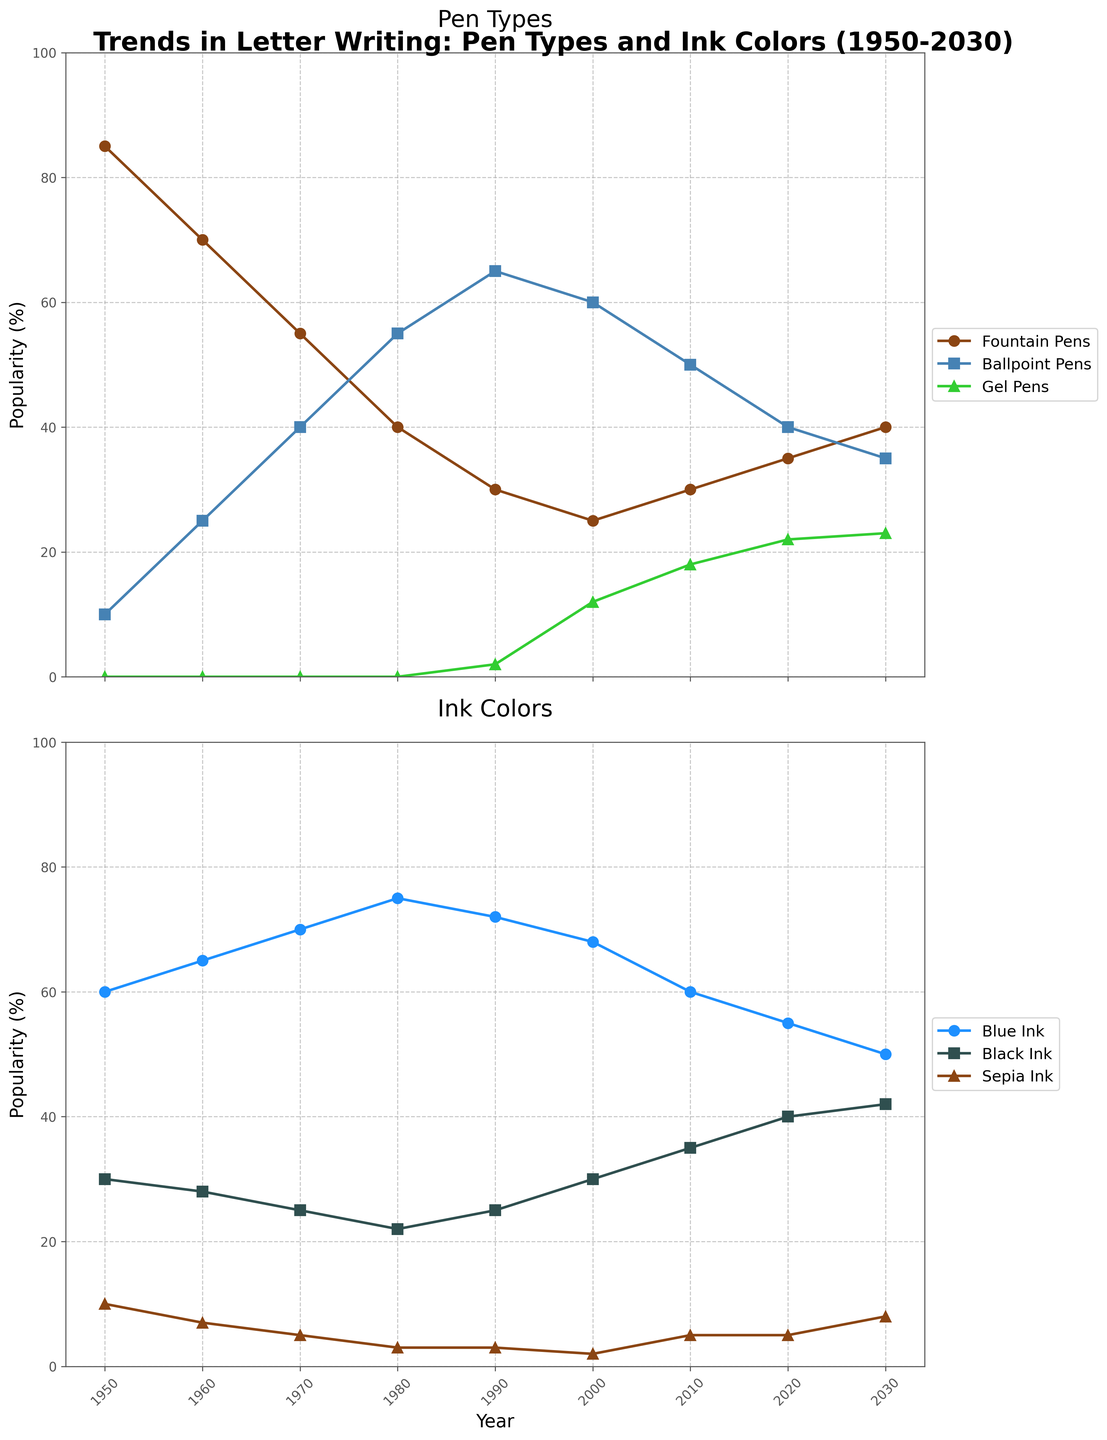what is the trend of fountain pens' popularity from 1950 to 2030? From the figure, the popularity of fountain pens declines from 85% in 1950 to a low of 25% in 2000 after which it starts to gradually increase, reaching up to 40% by 2030.
Answer: An initial decline, followed by a gradual increase Are gel pens more popular than ballpoint pens in 2030? In the figure, gel pens are at 23% while ballpoint pens are at 35% in 2030. Since 23% is less than 35%, gel pens are less popular than ballpoint pens in 2030.
Answer: No In which year did ballpoint pens surpass fountain pens in popularity? According to the figure, ballpoint pens’ popularity exceeds that of fountain pens between 1970 and 1980. In 1970, ballpoint pens are at 40% compared to fountain pens at 55%. By 1980, ballpoint pens reach 55%, and fountain pens fall to 40%. Thus, ballpoint pens surpass fountain pens around 1975.
Answer: Around 1975 What is the total combined popularity of blue ink, black ink, and sepia ink in 2020? From the figure, blue ink is at 55%, black ink at 40%, and sepia ink at 5% in 2020. Adding these percentages gives 55% + 40% + 5% = 100%.
Answer: 100% How does the popularity of sepia ink change from 1950 to 2030? According to the figure, sepia ink starts at 10% in 1950, gradually declines to 2% in 2000, then slightly increases to 8% by 2030.
Answer: Gradual decline followed by a slight increase Which ink color surpasses the other in popularity around 2000, blue ink or black ink? In the year 2000, the popularity of blue ink is 68% while black ink is 30%. Comparing these percentages, blue ink is more popular than black ink.
Answer: Blue ink What is the average popularity of ballpoint pens from 1950 to 2030? To find the average, add the popularity of ballpoint pens for all years given and divide by the number of years: (10 + 25 + 40 + 55 + 65 + 60 + 50 + 40 + 35) / 9. Summing these up gives 380. Dividing by 9, the average is 42.22.
Answer: 42.22% In which year is the popularity of fountain pens and gel pens equal? Observing the figure, fountain pens and gel pens have equal popularity of 30% around the year 2000.
Answer: Around 2000 Which pen type shows the most consistent increase in popularity? Referring to the figure, gel pens show a consistent increase in popularity from their introduction in 1990 with a 2% share, rising steadily to 23% by 2030.
Answer: Gel Pens 